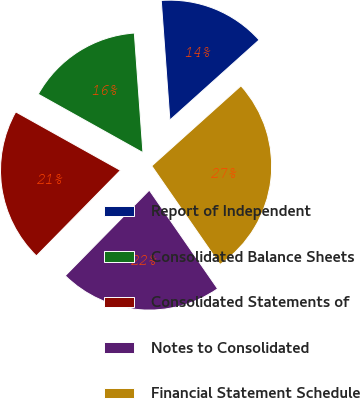Convert chart to OTSL. <chart><loc_0><loc_0><loc_500><loc_500><pie_chart><fcel>Report of Independent<fcel>Consolidated Balance Sheets<fcel>Consolidated Statements of<fcel>Notes to Consolidated<fcel>Financial Statement Schedule<nl><fcel>14.5%<fcel>15.75%<fcel>20.75%<fcel>22.0%<fcel>27.0%<nl></chart> 